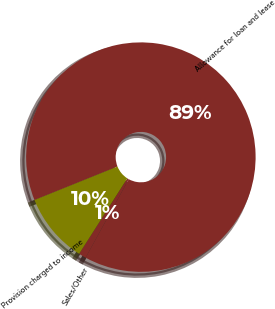<chart> <loc_0><loc_0><loc_500><loc_500><pie_chart><fcel>Allowance for loan and lease<fcel>Sales/Other<fcel>Provision charged to income<nl><fcel>89.1%<fcel>1.05%<fcel>9.85%<nl></chart> 